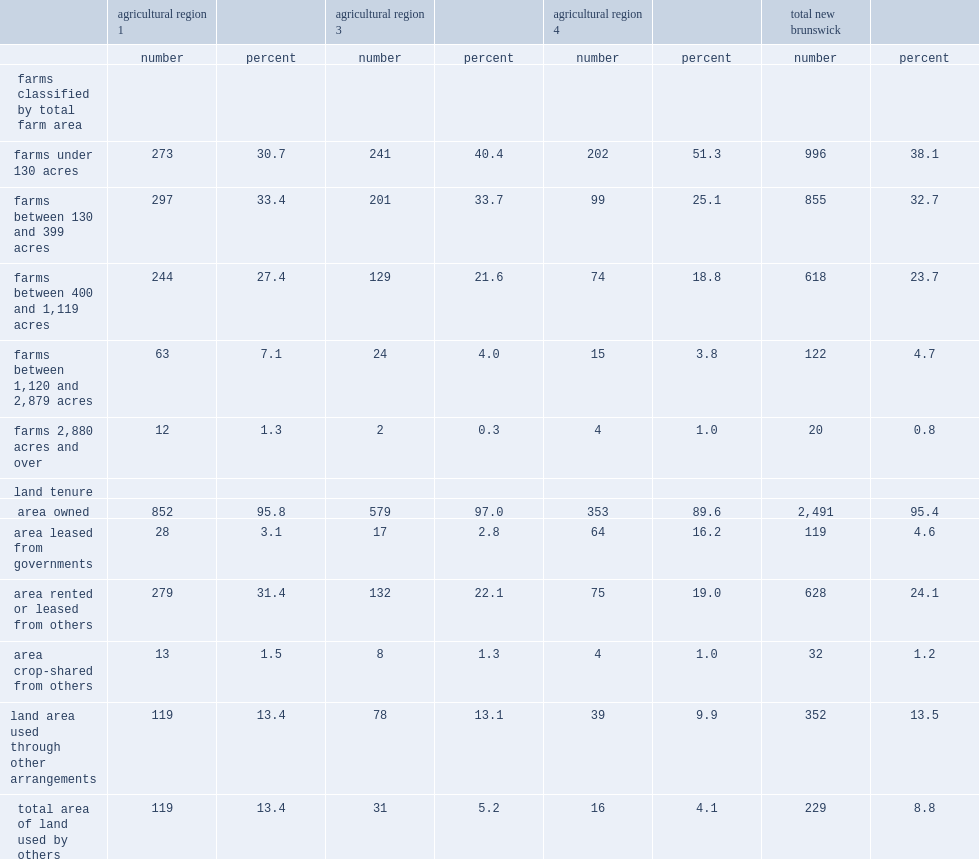Give me the full table as a dictionary. {'header': ['', 'agricultural region 1', '', 'agricultural region 3', '', 'agricultural region 4', '', 'total new brunswick', ''], 'rows': [['', 'number', 'percent', 'number', 'percent', 'number', 'percent', 'number', 'percent'], ['farms classified by total farm area', '', '', '', '', '', '', '', ''], ['farms under 130 acres', '273', '30.7', '241', '40.4', '202', '51.3', '996', '38.1'], ['farms between 130 and 399 acres', '297', '33.4', '201', '33.7', '99', '25.1', '855', '32.7'], ['farms between 400 and 1,119 acres', '244', '27.4', '129', '21.6', '74', '18.8', '618', '23.7'], ['farms between 1,120 and 2,879 acres', '63', '7.1', '24', '4.0', '15', '3.8', '122', '4.7'], ['farms 2,880 acres and over', '12', '1.3', '2', '0.3', '4', '1.0', '20', '0.8'], ['land tenure', '', '', '', '', '', '', '', ''], ['area owned', '852', '95.8', '579', '97.0', '353', '89.6', '2,491', '95.4'], ['area leased from governments', '28', '3.1', '17', '2.8', '64', '16.2', '119', '4.6'], ['area rented or leased from others', '279', '31.4', '132', '22.1', '75', '19.0', '628', '24.1'], ['area crop-shared from others', '13', '1.5', '8', '1.3', '4', '1.0', '32', '1.2'], ['land area used through other arrangements', '119', '13.4', '78', '13.1', '39', '9.9', '352', '13.5'], ['total area of land used by others', '119', '13.4', '31', '5.2', '16', '4.1', '229', '8.8']]} What kind of land tenure has the proportion of operators declared that of land tenure to all decalred land tenure ranging from 89.6% in agricultural region 4 to 97.0% in agricultural region 3? Area owned. Compared with all farms in the province, which agricultural region has more farms owned land? Agricultural region 3. Compared with all farms in the province, which agricultural region has fewer farms owned land? Agricultural region 4. 